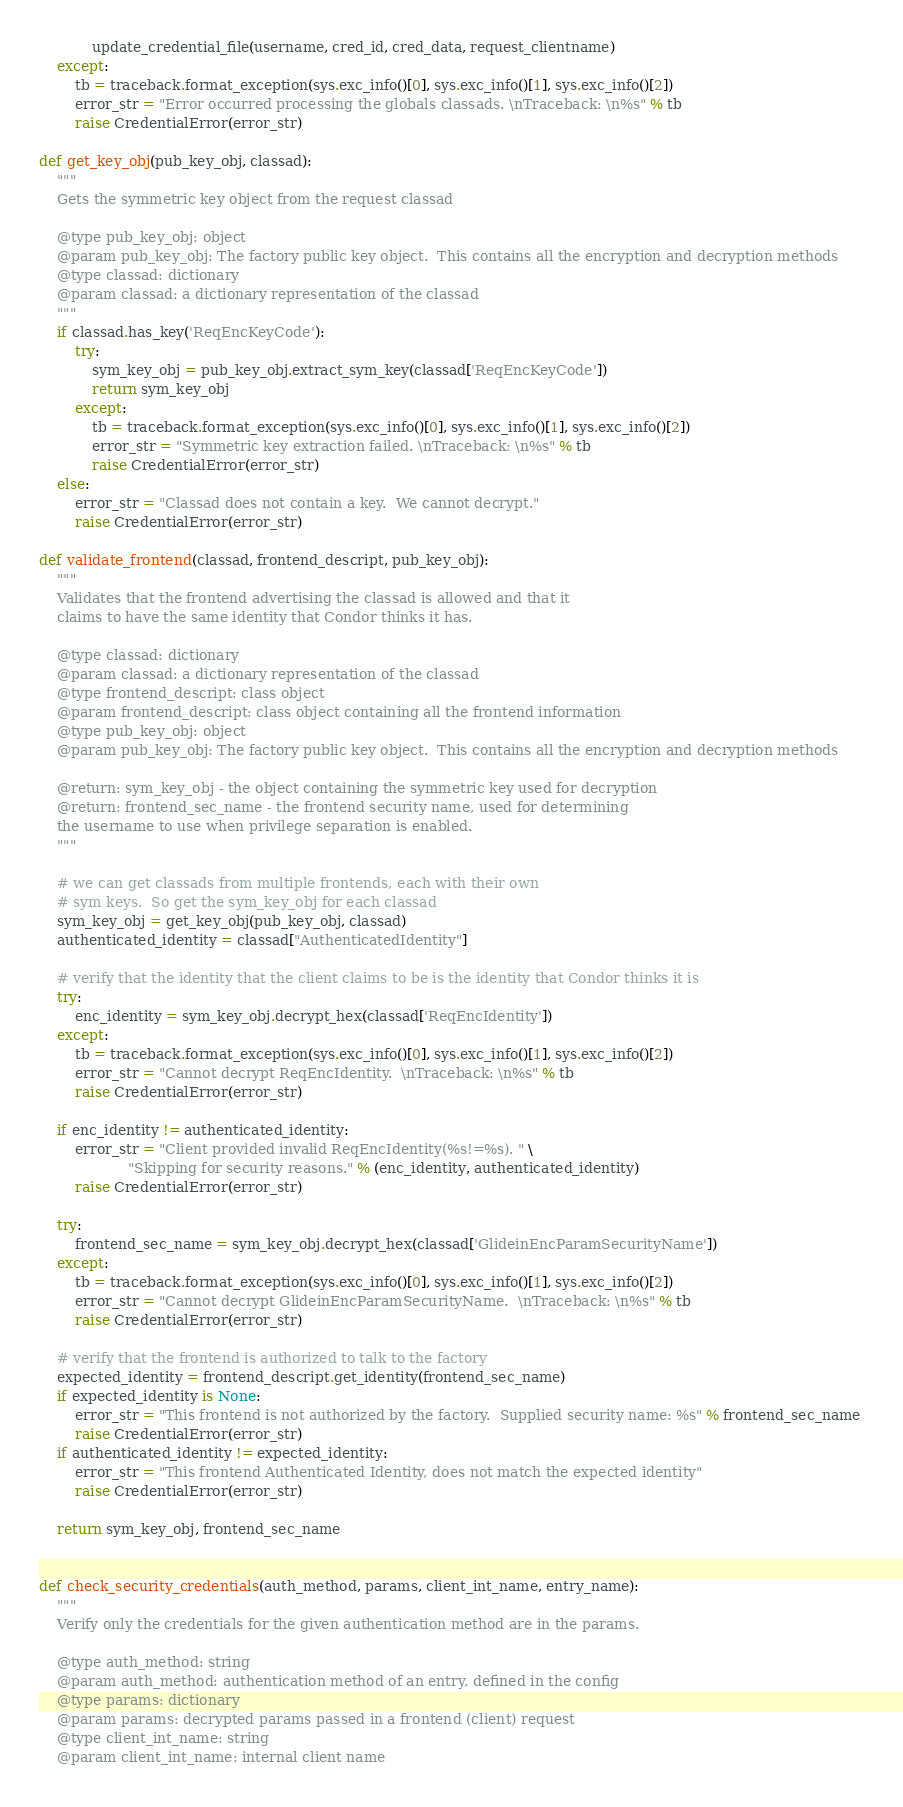Convert code to text. <code><loc_0><loc_0><loc_500><loc_500><_Python_>            update_credential_file(username, cred_id, cred_data, request_clientname)
    except:
        tb = traceback.format_exception(sys.exc_info()[0], sys.exc_info()[1], sys.exc_info()[2])
        error_str = "Error occurred processing the globals classads. \nTraceback: \n%s" % tb
        raise CredentialError(error_str)

def get_key_obj(pub_key_obj, classad):
    """
    Gets the symmetric key object from the request classad

    @type pub_key_obj: object
    @param pub_key_obj: The factory public key object.  This contains all the encryption and decryption methods
    @type classad: dictionary
    @param classad: a dictionary representation of the classad
    """
    if classad.has_key('ReqEncKeyCode'):
        try:
            sym_key_obj = pub_key_obj.extract_sym_key(classad['ReqEncKeyCode'])
            return sym_key_obj
        except:
            tb = traceback.format_exception(sys.exc_info()[0], sys.exc_info()[1], sys.exc_info()[2])
            error_str = "Symmetric key extraction failed. \nTraceback: \n%s" % tb
            raise CredentialError(error_str)
    else:
        error_str = "Classad does not contain a key.  We cannot decrypt."
        raise CredentialError(error_str)

def validate_frontend(classad, frontend_descript, pub_key_obj):
    """
    Validates that the frontend advertising the classad is allowed and that it
    claims to have the same identity that Condor thinks it has.

    @type classad: dictionary
    @param classad: a dictionary representation of the classad
    @type frontend_descript: class object
    @param frontend_descript: class object containing all the frontend information
    @type pub_key_obj: object
    @param pub_key_obj: The factory public key object.  This contains all the encryption and decryption methods

    @return: sym_key_obj - the object containing the symmetric key used for decryption
    @return: frontend_sec_name - the frontend security name, used for determining
    the username to use when privilege separation is enabled.
    """

    # we can get classads from multiple frontends, each with their own
    # sym keys.  So get the sym_key_obj for each classad
    sym_key_obj = get_key_obj(pub_key_obj, classad)
    authenticated_identity = classad["AuthenticatedIdentity"]

    # verify that the identity that the client claims to be is the identity that Condor thinks it is 
    try:
        enc_identity = sym_key_obj.decrypt_hex(classad['ReqEncIdentity'])
    except:
        tb = traceback.format_exception(sys.exc_info()[0], sys.exc_info()[1], sys.exc_info()[2])
        error_str = "Cannot decrypt ReqEncIdentity.  \nTraceback: \n%s" % tb
        raise CredentialError(error_str)

    if enc_identity != authenticated_identity:
        error_str = "Client provided invalid ReqEncIdentity(%s!=%s). " \
                    "Skipping for security reasons." % (enc_identity, authenticated_identity)
        raise CredentialError(error_str)

    try:
        frontend_sec_name = sym_key_obj.decrypt_hex(classad['GlideinEncParamSecurityName'])
    except:
        tb = traceback.format_exception(sys.exc_info()[0], sys.exc_info()[1], sys.exc_info()[2])
        error_str = "Cannot decrypt GlideinEncParamSecurityName.  \nTraceback: \n%s" % tb
        raise CredentialError(error_str)

    # verify that the frontend is authorized to talk to the factory
    expected_identity = frontend_descript.get_identity(frontend_sec_name)
    if expected_identity is None:
        error_str = "This frontend is not authorized by the factory.  Supplied security name: %s" % frontend_sec_name 
        raise CredentialError(error_str)
    if authenticated_identity != expected_identity:
        error_str = "This frontend Authenticated Identity, does not match the expected identity"
        raise CredentialError(error_str)

    return sym_key_obj, frontend_sec_name


def check_security_credentials(auth_method, params, client_int_name, entry_name):
    """
    Verify only the credentials for the given authentication method are in the params.
    
    @type auth_method: string
    @param auth_method: authentication method of an entry, defined in the config
    @type params: dictionary
    @param params: decrypted params passed in a frontend (client) request
    @type client_int_name: string
    @param client_int_name: internal client name</code> 